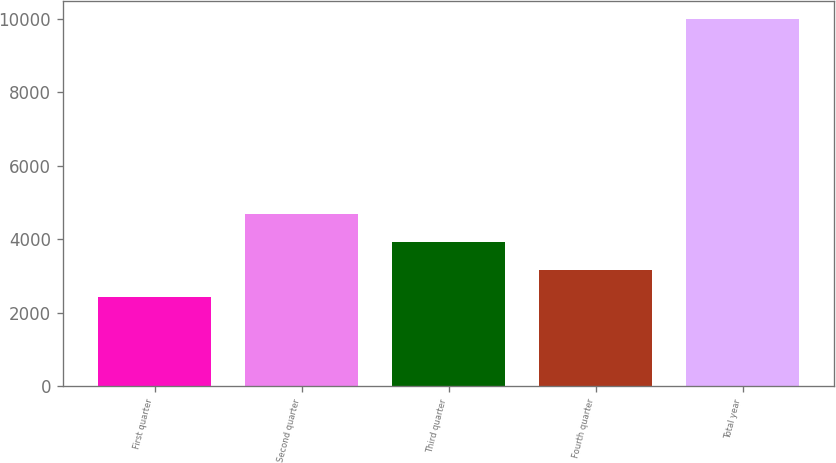Convert chart to OTSL. <chart><loc_0><loc_0><loc_500><loc_500><bar_chart><fcel>First quarter<fcel>Second quarter<fcel>Third quarter<fcel>Fourth quarter<fcel>Total year<nl><fcel>2412.2<fcel>4683.62<fcel>3926.48<fcel>3169.34<fcel>9983.6<nl></chart> 